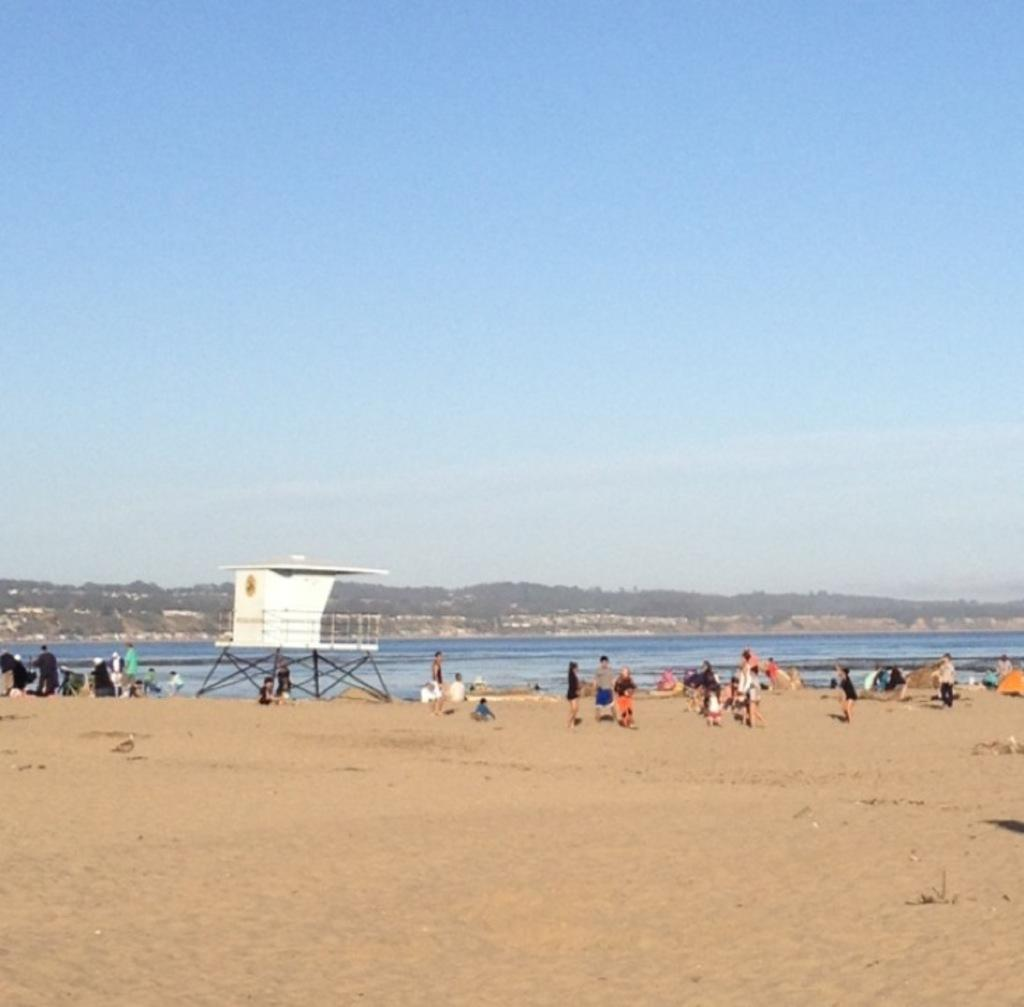What is the setting of the image? The setting of the image is on the sand, with people present. What can be seen in the background of the image? There is water visible in the image, as well as hills. What is the condition of the sky in the image? Clouds are present in the sky in the image. What book is being read by the person on the sand in the image? There is no book visible in the image, and no person is shown reading. 